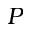Convert formula to latex. <formula><loc_0><loc_0><loc_500><loc_500>P</formula> 